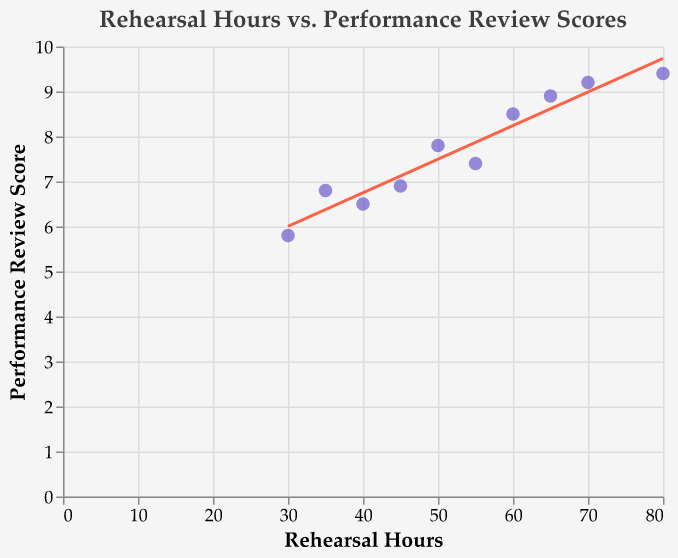What is the title of the figure? The title is written at the top center of the figure and it says "Rehearsal Hours vs. Performance Review Scores".
Answer: "Rehearsal Hours vs. Performance Review Scores" How many data points are there in the figure? You can count the number of points scattered on the plot; there are 10 data points visible.
Answer: 10 What are the variables represented on the x-axis and y-axis? The x-axis represents "Rehearsal Hours", and the y-axis represents "Performance Review Score".
Answer: "Rehearsal Hours" and "Performance Review Score" Which theater company has the highest performance review score? Look for the point with the highest position on the y-axis and check the tooltip information. The company is "Unconventional Productions".
Answer: "Unconventional Productions" What is the performance review score for the "New Theatre Workshop"? Hovering over the point associated with "New Theatre Workshop", you will see in the tooltip that its performance review score is 7.8.
Answer: 7.8 Which theater company has the lowest rehearsal hours and what is its performance review score? Identify the point with the smallest x-value (rehearsal hours), and from the tooltip, you find that "Radical Stage Craft" has 30 rehearsal hours and a performance review score of 5.8.
Answer: "Radical Stage Craft" and 5.8 What's the average rehearsal time for theater companies scoring above 8? Identify the data points with performance review scores above 8: "Experimental Stage" (65 hours), "Boundary Breakers Theatre" (70 hours), "Cutting Edge Ensemble" (60 hours), and "Unconventional Productions" (80 hours). Sum these hours (65 + 70 + 60 + 80 = 275) and divide by the number of companies (4).
Answer: 68.75 hours How would you describe the trend shown by the trend line? The trend line rises from left to right, which indicates a positive correlation between the number of rehearsal hours and the performance review scores.
Answer: Positive correlation Which theater companies fall below the trend line? Points below the trend line can be identified visually. They are "New Theatre Workshop", "Innovative Performers", "Theatre of the New", and "Radical Stage Craft".
Answer: "New Theatre Workshop", "Innovative Performers", "Theatre of the New", and "Radical Stage Craft" What can be inferred from the trend line about the relationship between rehearse time and performance review scores? The trend line shows an upward slope, which implies that, generally, as the number of rehearsal hours increases, the performance review scores tend to improve.
Answer: More rehearsal hours generally lead to better performance review scores 